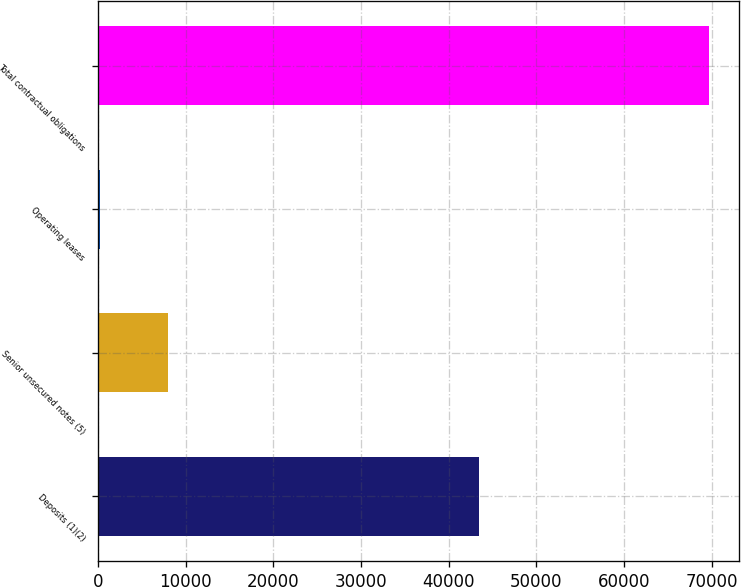Convert chart to OTSL. <chart><loc_0><loc_0><loc_500><loc_500><bar_chart><fcel>Deposits (1)(2)<fcel>Senior unsecured notes (5)<fcel>Operating leases<fcel>Total contractual obligations<nl><fcel>43447<fcel>7943<fcel>204<fcel>69676<nl></chart> 